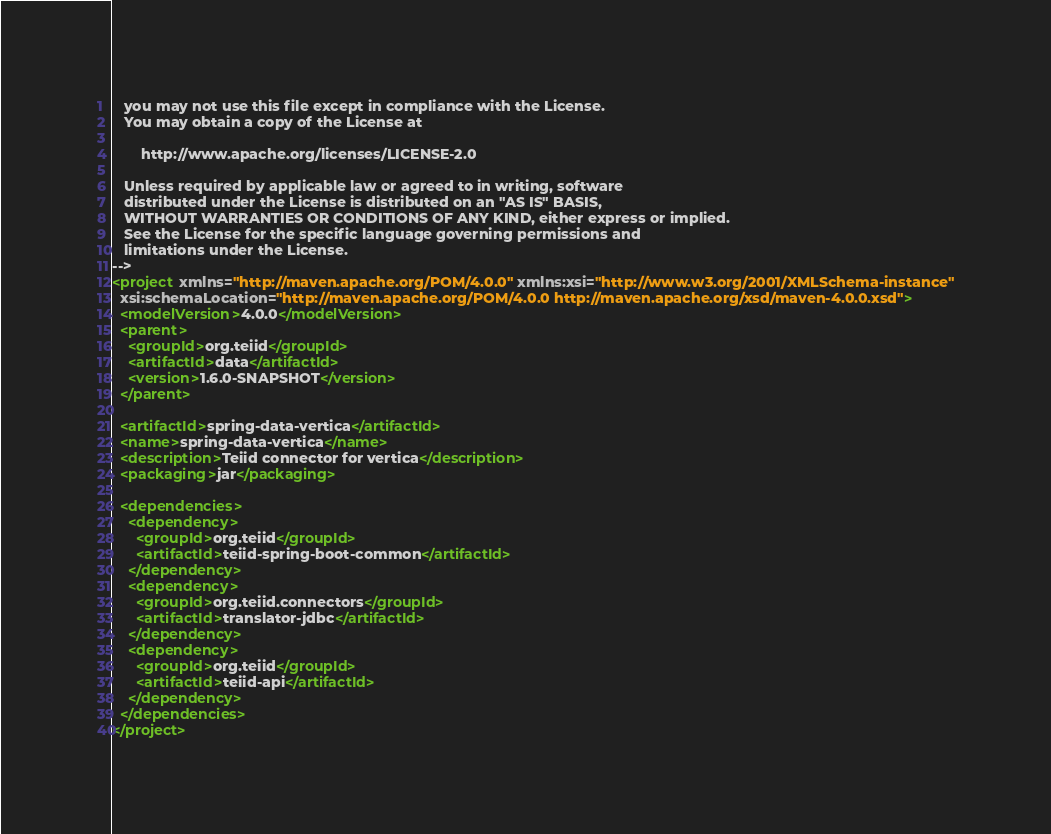Convert code to text. <code><loc_0><loc_0><loc_500><loc_500><_XML_>   you may not use this file except in compliance with the License.
   You may obtain a copy of the License at

       http://www.apache.org/licenses/LICENSE-2.0

   Unless required by applicable law or agreed to in writing, software
   distributed under the License is distributed on an "AS IS" BASIS,
   WITHOUT WARRANTIES OR CONDITIONS OF ANY KIND, either express or implied.
   See the License for the specific language governing permissions and
   limitations under the License.
-->
<project xmlns="http://maven.apache.org/POM/4.0.0" xmlns:xsi="http://www.w3.org/2001/XMLSchema-instance"
  xsi:schemaLocation="http://maven.apache.org/POM/4.0.0 http://maven.apache.org/xsd/maven-4.0.0.xsd">
  <modelVersion>4.0.0</modelVersion>
  <parent>
    <groupId>org.teiid</groupId>
    <artifactId>data</artifactId>
    <version>1.6.0-SNAPSHOT</version>
  </parent>

  <artifactId>spring-data-vertica</artifactId>
  <name>spring-data-vertica</name>
  <description>Teiid connector for vertica</description>
  <packaging>jar</packaging>

  <dependencies>
    <dependency>
      <groupId>org.teiid</groupId>
      <artifactId>teiid-spring-boot-common</artifactId>
    </dependency>
    <dependency>
      <groupId>org.teiid.connectors</groupId>
      <artifactId>translator-jdbc</artifactId>
    </dependency>
    <dependency>
      <groupId>org.teiid</groupId>
      <artifactId>teiid-api</artifactId>
    </dependency>
  </dependencies>
</project>
</code> 